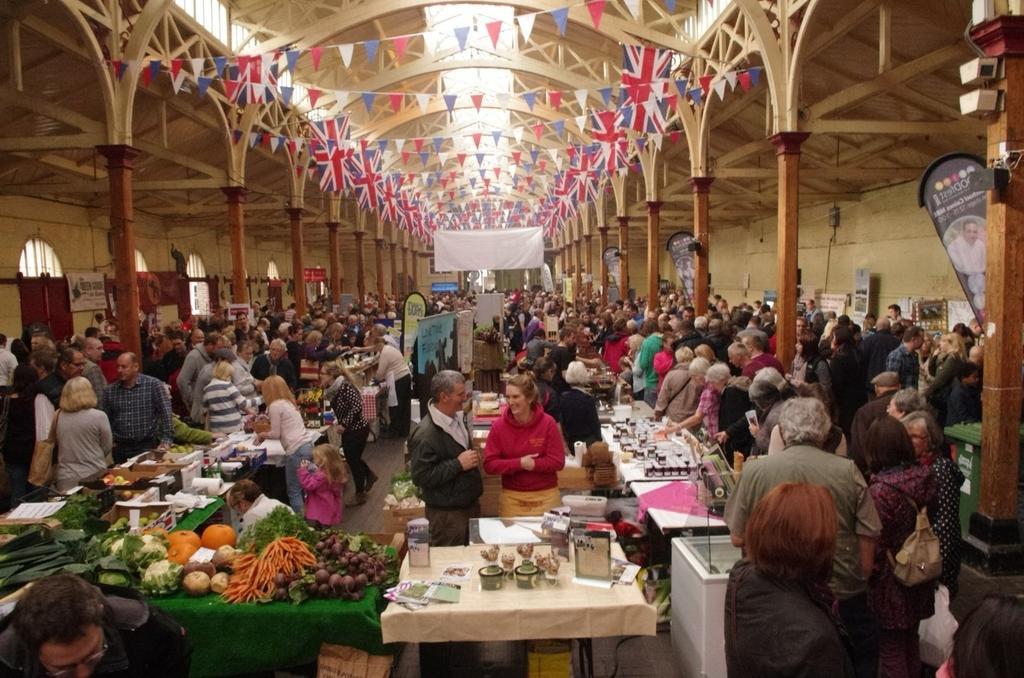In one or two sentences, can you explain what this image depicts? In the image there are many people standing. There are tables with vegetables and some other items. There are pillars, walls with posters and doors. At the top of the image there are decorative flags. 